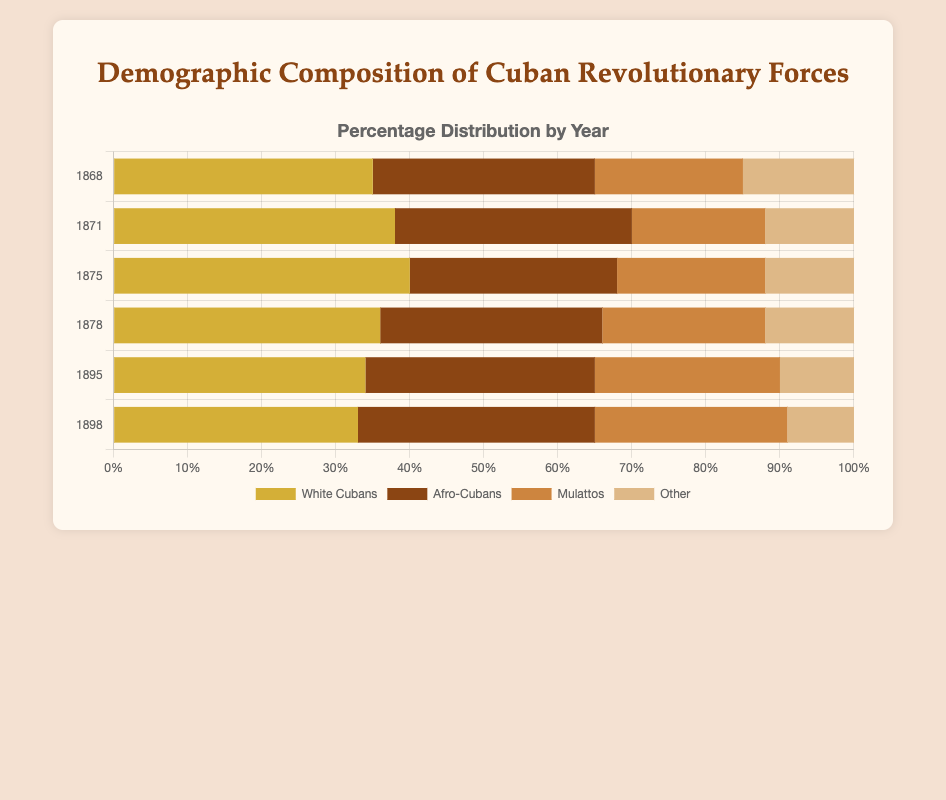What's the percentage change in the proportion of "White Cubans" from 1868 to 1898? In 1868, the percentage of "White Cubans" is 35%. In 1898, it is 33%. The change is 33% - 35% = -2%. Therefore, the percentage change is -2%.
Answer: -2% Which demographic group saw the greatest increase in their proportion from 1868 to 1898? In 1868, Afro-Cubans were 30%, and in 1898 they were 32%. Mulattos rose from 20% to 26%. Other decreased from 15% to 9%. Therefore, the group with the greatest increase is Mulattos with a change of 26% - 20% = 6%.
Answer: Mulattos Between which years did the proportion of "Afro-Cubans" remain the same? "Afro-Cubans" were 30% in 1868, 32% in 1871, 28% in 1875, 30% in 1878, 31% in 1895, and 32% in 1898. Hence, the proportion remained the same in the years 1868 and 1878, and 1898.
Answer: None Which group saw their proportion consistently decrease over time? "Other" started at 15% in 1868 and dropped to 9% by 1898, without any increase in between.
Answer: Other What is the total percentage of "White Cubans" and "Afro-Cubans" in 1875? The percentage of "White Cubans" in 1875 is 40% and "Afro-Cubans" is 28%. Their total is 40% + 28% = 68%.
Answer: 68% When did "White Cubans" have their peak proportion, and what was it? "White Cubans" had their peak proportion in 1875 with a percentage of 40%.
Answer: 1875 Are "Afro-Cubans" ever the majority group in any year? For each year: 1868 (30%), 1871 (32%), 1875 (28%), 1878 (30%), 1895 (31%), 1898 (32%). In none of these years do "Afro-Cubans" exceed the proportion of "White Cubans".
Answer: No Which demographic's proportion remained the most stable over the years? "White Cubans" ranged between 33% to 40%, "Afro-Cubans" between 28% to 32%, "Mulattos" from 18% to 26%, and "Other" from 9% to 15%. "Afro-Cubans" had the smallest range from 28% to 32%, making it the most stable group.
Answer: Afro-Cubans 